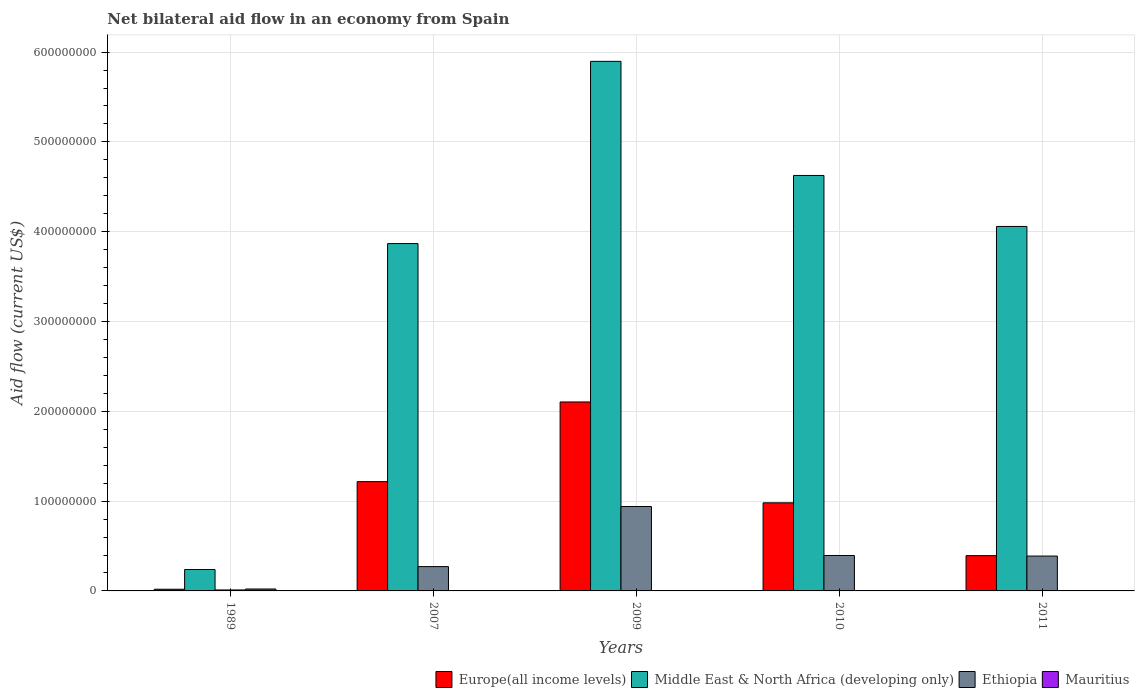How many different coloured bars are there?
Offer a very short reply. 4. Are the number of bars per tick equal to the number of legend labels?
Offer a terse response. Yes. How many bars are there on the 3rd tick from the left?
Give a very brief answer. 4. What is the label of the 1st group of bars from the left?
Your answer should be compact. 1989. What is the net bilateral aid flow in Europe(all income levels) in 1989?
Make the answer very short. 1.87e+06. Across all years, what is the maximum net bilateral aid flow in Ethiopia?
Make the answer very short. 9.40e+07. Across all years, what is the minimum net bilateral aid flow in Europe(all income levels)?
Make the answer very short. 1.87e+06. In which year was the net bilateral aid flow in Europe(all income levels) maximum?
Provide a short and direct response. 2009. In which year was the net bilateral aid flow in Europe(all income levels) minimum?
Offer a terse response. 1989. What is the total net bilateral aid flow in Middle East & North Africa (developing only) in the graph?
Your answer should be very brief. 1.87e+09. What is the difference between the net bilateral aid flow in Ethiopia in 1989 and that in 2010?
Your answer should be compact. -3.84e+07. What is the difference between the net bilateral aid flow in Europe(all income levels) in 2007 and the net bilateral aid flow in Mauritius in 2011?
Keep it short and to the point. 1.22e+08. What is the average net bilateral aid flow in Ethiopia per year?
Ensure brevity in your answer.  4.01e+07. In the year 2010, what is the difference between the net bilateral aid flow in Middle East & North Africa (developing only) and net bilateral aid flow in Mauritius?
Your answer should be very brief. 4.63e+08. What is the ratio of the net bilateral aid flow in Ethiopia in 1989 to that in 2011?
Provide a short and direct response. 0.03. Is the difference between the net bilateral aid flow in Middle East & North Africa (developing only) in 1989 and 2007 greater than the difference between the net bilateral aid flow in Mauritius in 1989 and 2007?
Your response must be concise. No. What is the difference between the highest and the second highest net bilateral aid flow in Ethiopia?
Ensure brevity in your answer.  5.45e+07. What is the difference between the highest and the lowest net bilateral aid flow in Ethiopia?
Provide a succinct answer. 9.29e+07. In how many years, is the net bilateral aid flow in Middle East & North Africa (developing only) greater than the average net bilateral aid flow in Middle East & North Africa (developing only) taken over all years?
Your response must be concise. 4. What does the 2nd bar from the left in 2010 represents?
Keep it short and to the point. Middle East & North Africa (developing only). What does the 3rd bar from the right in 2011 represents?
Your answer should be very brief. Middle East & North Africa (developing only). How many bars are there?
Ensure brevity in your answer.  20. What is the difference between two consecutive major ticks on the Y-axis?
Keep it short and to the point. 1.00e+08. Does the graph contain any zero values?
Make the answer very short. No. Does the graph contain grids?
Keep it short and to the point. Yes. How many legend labels are there?
Keep it short and to the point. 4. How are the legend labels stacked?
Offer a terse response. Horizontal. What is the title of the graph?
Provide a short and direct response. Net bilateral aid flow in an economy from Spain. What is the label or title of the Y-axis?
Give a very brief answer. Aid flow (current US$). What is the Aid flow (current US$) of Europe(all income levels) in 1989?
Offer a very short reply. 1.87e+06. What is the Aid flow (current US$) in Middle East & North Africa (developing only) in 1989?
Give a very brief answer. 2.38e+07. What is the Aid flow (current US$) in Ethiopia in 1989?
Your response must be concise. 1.09e+06. What is the Aid flow (current US$) in Mauritius in 1989?
Your answer should be very brief. 2.14e+06. What is the Aid flow (current US$) in Europe(all income levels) in 2007?
Offer a terse response. 1.22e+08. What is the Aid flow (current US$) of Middle East & North Africa (developing only) in 2007?
Ensure brevity in your answer.  3.87e+08. What is the Aid flow (current US$) in Ethiopia in 2007?
Ensure brevity in your answer.  2.71e+07. What is the Aid flow (current US$) of Mauritius in 2007?
Your response must be concise. 10000. What is the Aid flow (current US$) in Europe(all income levels) in 2009?
Your answer should be very brief. 2.10e+08. What is the Aid flow (current US$) in Middle East & North Africa (developing only) in 2009?
Provide a succinct answer. 5.90e+08. What is the Aid flow (current US$) of Ethiopia in 2009?
Offer a terse response. 9.40e+07. What is the Aid flow (current US$) in Mauritius in 2009?
Give a very brief answer. 2.00e+04. What is the Aid flow (current US$) of Europe(all income levels) in 2010?
Offer a terse response. 9.81e+07. What is the Aid flow (current US$) in Middle East & North Africa (developing only) in 2010?
Offer a very short reply. 4.63e+08. What is the Aid flow (current US$) of Ethiopia in 2010?
Give a very brief answer. 3.95e+07. What is the Aid flow (current US$) in Europe(all income levels) in 2011?
Keep it short and to the point. 3.93e+07. What is the Aid flow (current US$) in Middle East & North Africa (developing only) in 2011?
Make the answer very short. 4.06e+08. What is the Aid flow (current US$) of Ethiopia in 2011?
Keep it short and to the point. 3.88e+07. What is the Aid flow (current US$) of Mauritius in 2011?
Keep it short and to the point. 3.00e+04. Across all years, what is the maximum Aid flow (current US$) in Europe(all income levels)?
Your answer should be very brief. 2.10e+08. Across all years, what is the maximum Aid flow (current US$) of Middle East & North Africa (developing only)?
Provide a succinct answer. 5.90e+08. Across all years, what is the maximum Aid flow (current US$) in Ethiopia?
Give a very brief answer. 9.40e+07. Across all years, what is the maximum Aid flow (current US$) in Mauritius?
Provide a short and direct response. 2.14e+06. Across all years, what is the minimum Aid flow (current US$) of Europe(all income levels)?
Make the answer very short. 1.87e+06. Across all years, what is the minimum Aid flow (current US$) in Middle East & North Africa (developing only)?
Keep it short and to the point. 2.38e+07. Across all years, what is the minimum Aid flow (current US$) of Ethiopia?
Your answer should be compact. 1.09e+06. Across all years, what is the minimum Aid flow (current US$) in Mauritius?
Your answer should be very brief. 10000. What is the total Aid flow (current US$) of Europe(all income levels) in the graph?
Ensure brevity in your answer.  4.71e+08. What is the total Aid flow (current US$) in Middle East & North Africa (developing only) in the graph?
Provide a succinct answer. 1.87e+09. What is the total Aid flow (current US$) of Ethiopia in the graph?
Your response must be concise. 2.00e+08. What is the total Aid flow (current US$) of Mauritius in the graph?
Offer a terse response. 2.23e+06. What is the difference between the Aid flow (current US$) of Europe(all income levels) in 1989 and that in 2007?
Make the answer very short. -1.20e+08. What is the difference between the Aid flow (current US$) of Middle East & North Africa (developing only) in 1989 and that in 2007?
Make the answer very short. -3.63e+08. What is the difference between the Aid flow (current US$) in Ethiopia in 1989 and that in 2007?
Provide a succinct answer. -2.60e+07. What is the difference between the Aid flow (current US$) of Mauritius in 1989 and that in 2007?
Make the answer very short. 2.13e+06. What is the difference between the Aid flow (current US$) in Europe(all income levels) in 1989 and that in 2009?
Keep it short and to the point. -2.09e+08. What is the difference between the Aid flow (current US$) in Middle East & North Africa (developing only) in 1989 and that in 2009?
Your answer should be very brief. -5.66e+08. What is the difference between the Aid flow (current US$) in Ethiopia in 1989 and that in 2009?
Your answer should be compact. -9.29e+07. What is the difference between the Aid flow (current US$) in Mauritius in 1989 and that in 2009?
Provide a short and direct response. 2.12e+06. What is the difference between the Aid flow (current US$) of Europe(all income levels) in 1989 and that in 2010?
Offer a terse response. -9.62e+07. What is the difference between the Aid flow (current US$) in Middle East & North Africa (developing only) in 1989 and that in 2010?
Ensure brevity in your answer.  -4.39e+08. What is the difference between the Aid flow (current US$) of Ethiopia in 1989 and that in 2010?
Make the answer very short. -3.84e+07. What is the difference between the Aid flow (current US$) of Mauritius in 1989 and that in 2010?
Give a very brief answer. 2.11e+06. What is the difference between the Aid flow (current US$) in Europe(all income levels) in 1989 and that in 2011?
Your answer should be very brief. -3.74e+07. What is the difference between the Aid flow (current US$) in Middle East & North Africa (developing only) in 1989 and that in 2011?
Provide a succinct answer. -3.82e+08. What is the difference between the Aid flow (current US$) of Ethiopia in 1989 and that in 2011?
Your answer should be compact. -3.77e+07. What is the difference between the Aid flow (current US$) of Mauritius in 1989 and that in 2011?
Offer a terse response. 2.11e+06. What is the difference between the Aid flow (current US$) of Europe(all income levels) in 2007 and that in 2009?
Make the answer very short. -8.87e+07. What is the difference between the Aid flow (current US$) of Middle East & North Africa (developing only) in 2007 and that in 2009?
Provide a short and direct response. -2.03e+08. What is the difference between the Aid flow (current US$) in Ethiopia in 2007 and that in 2009?
Make the answer very short. -6.69e+07. What is the difference between the Aid flow (current US$) in Mauritius in 2007 and that in 2009?
Ensure brevity in your answer.  -10000. What is the difference between the Aid flow (current US$) in Europe(all income levels) in 2007 and that in 2010?
Provide a succinct answer. 2.36e+07. What is the difference between the Aid flow (current US$) in Middle East & North Africa (developing only) in 2007 and that in 2010?
Keep it short and to the point. -7.59e+07. What is the difference between the Aid flow (current US$) in Ethiopia in 2007 and that in 2010?
Provide a succinct answer. -1.24e+07. What is the difference between the Aid flow (current US$) in Europe(all income levels) in 2007 and that in 2011?
Make the answer very short. 8.24e+07. What is the difference between the Aid flow (current US$) in Middle East & North Africa (developing only) in 2007 and that in 2011?
Give a very brief answer. -1.91e+07. What is the difference between the Aid flow (current US$) in Ethiopia in 2007 and that in 2011?
Your answer should be compact. -1.17e+07. What is the difference between the Aid flow (current US$) of Europe(all income levels) in 2009 and that in 2010?
Make the answer very short. 1.12e+08. What is the difference between the Aid flow (current US$) of Middle East & North Africa (developing only) in 2009 and that in 2010?
Offer a terse response. 1.27e+08. What is the difference between the Aid flow (current US$) in Ethiopia in 2009 and that in 2010?
Your answer should be compact. 5.45e+07. What is the difference between the Aid flow (current US$) of Mauritius in 2009 and that in 2010?
Your answer should be compact. -10000. What is the difference between the Aid flow (current US$) in Europe(all income levels) in 2009 and that in 2011?
Make the answer very short. 1.71e+08. What is the difference between the Aid flow (current US$) of Middle East & North Africa (developing only) in 2009 and that in 2011?
Offer a very short reply. 1.84e+08. What is the difference between the Aid flow (current US$) in Ethiopia in 2009 and that in 2011?
Offer a terse response. 5.52e+07. What is the difference between the Aid flow (current US$) in Europe(all income levels) in 2010 and that in 2011?
Your answer should be very brief. 5.88e+07. What is the difference between the Aid flow (current US$) of Middle East & North Africa (developing only) in 2010 and that in 2011?
Your answer should be very brief. 5.68e+07. What is the difference between the Aid flow (current US$) of Ethiopia in 2010 and that in 2011?
Your answer should be compact. 6.40e+05. What is the difference between the Aid flow (current US$) of Europe(all income levels) in 1989 and the Aid flow (current US$) of Middle East & North Africa (developing only) in 2007?
Offer a terse response. -3.85e+08. What is the difference between the Aid flow (current US$) of Europe(all income levels) in 1989 and the Aid flow (current US$) of Ethiopia in 2007?
Give a very brief answer. -2.52e+07. What is the difference between the Aid flow (current US$) of Europe(all income levels) in 1989 and the Aid flow (current US$) of Mauritius in 2007?
Offer a very short reply. 1.86e+06. What is the difference between the Aid flow (current US$) of Middle East & North Africa (developing only) in 1989 and the Aid flow (current US$) of Ethiopia in 2007?
Give a very brief answer. -3.23e+06. What is the difference between the Aid flow (current US$) of Middle East & North Africa (developing only) in 1989 and the Aid flow (current US$) of Mauritius in 2007?
Give a very brief answer. 2.38e+07. What is the difference between the Aid flow (current US$) of Ethiopia in 1989 and the Aid flow (current US$) of Mauritius in 2007?
Offer a very short reply. 1.08e+06. What is the difference between the Aid flow (current US$) of Europe(all income levels) in 1989 and the Aid flow (current US$) of Middle East & North Africa (developing only) in 2009?
Offer a very short reply. -5.88e+08. What is the difference between the Aid flow (current US$) of Europe(all income levels) in 1989 and the Aid flow (current US$) of Ethiopia in 2009?
Your answer should be very brief. -9.21e+07. What is the difference between the Aid flow (current US$) of Europe(all income levels) in 1989 and the Aid flow (current US$) of Mauritius in 2009?
Provide a succinct answer. 1.85e+06. What is the difference between the Aid flow (current US$) of Middle East & North Africa (developing only) in 1989 and the Aid flow (current US$) of Ethiopia in 2009?
Your answer should be compact. -7.02e+07. What is the difference between the Aid flow (current US$) of Middle East & North Africa (developing only) in 1989 and the Aid flow (current US$) of Mauritius in 2009?
Offer a terse response. 2.38e+07. What is the difference between the Aid flow (current US$) of Ethiopia in 1989 and the Aid flow (current US$) of Mauritius in 2009?
Ensure brevity in your answer.  1.07e+06. What is the difference between the Aid flow (current US$) of Europe(all income levels) in 1989 and the Aid flow (current US$) of Middle East & North Africa (developing only) in 2010?
Make the answer very short. -4.61e+08. What is the difference between the Aid flow (current US$) of Europe(all income levels) in 1989 and the Aid flow (current US$) of Ethiopia in 2010?
Ensure brevity in your answer.  -3.76e+07. What is the difference between the Aid flow (current US$) in Europe(all income levels) in 1989 and the Aid flow (current US$) in Mauritius in 2010?
Make the answer very short. 1.84e+06. What is the difference between the Aid flow (current US$) of Middle East & North Africa (developing only) in 1989 and the Aid flow (current US$) of Ethiopia in 2010?
Your answer should be compact. -1.56e+07. What is the difference between the Aid flow (current US$) in Middle East & North Africa (developing only) in 1989 and the Aid flow (current US$) in Mauritius in 2010?
Ensure brevity in your answer.  2.38e+07. What is the difference between the Aid flow (current US$) of Ethiopia in 1989 and the Aid flow (current US$) of Mauritius in 2010?
Offer a terse response. 1.06e+06. What is the difference between the Aid flow (current US$) in Europe(all income levels) in 1989 and the Aid flow (current US$) in Middle East & North Africa (developing only) in 2011?
Ensure brevity in your answer.  -4.04e+08. What is the difference between the Aid flow (current US$) of Europe(all income levels) in 1989 and the Aid flow (current US$) of Ethiopia in 2011?
Ensure brevity in your answer.  -3.70e+07. What is the difference between the Aid flow (current US$) in Europe(all income levels) in 1989 and the Aid flow (current US$) in Mauritius in 2011?
Provide a short and direct response. 1.84e+06. What is the difference between the Aid flow (current US$) of Middle East & North Africa (developing only) in 1989 and the Aid flow (current US$) of Ethiopia in 2011?
Provide a succinct answer. -1.50e+07. What is the difference between the Aid flow (current US$) of Middle East & North Africa (developing only) in 1989 and the Aid flow (current US$) of Mauritius in 2011?
Keep it short and to the point. 2.38e+07. What is the difference between the Aid flow (current US$) in Ethiopia in 1989 and the Aid flow (current US$) in Mauritius in 2011?
Your answer should be very brief. 1.06e+06. What is the difference between the Aid flow (current US$) in Europe(all income levels) in 2007 and the Aid flow (current US$) in Middle East & North Africa (developing only) in 2009?
Ensure brevity in your answer.  -4.68e+08. What is the difference between the Aid flow (current US$) in Europe(all income levels) in 2007 and the Aid flow (current US$) in Ethiopia in 2009?
Ensure brevity in your answer.  2.77e+07. What is the difference between the Aid flow (current US$) of Europe(all income levels) in 2007 and the Aid flow (current US$) of Mauritius in 2009?
Keep it short and to the point. 1.22e+08. What is the difference between the Aid flow (current US$) of Middle East & North Africa (developing only) in 2007 and the Aid flow (current US$) of Ethiopia in 2009?
Offer a very short reply. 2.93e+08. What is the difference between the Aid flow (current US$) in Middle East & North Africa (developing only) in 2007 and the Aid flow (current US$) in Mauritius in 2009?
Make the answer very short. 3.87e+08. What is the difference between the Aid flow (current US$) in Ethiopia in 2007 and the Aid flow (current US$) in Mauritius in 2009?
Your answer should be compact. 2.71e+07. What is the difference between the Aid flow (current US$) of Europe(all income levels) in 2007 and the Aid flow (current US$) of Middle East & North Africa (developing only) in 2010?
Provide a succinct answer. -3.41e+08. What is the difference between the Aid flow (current US$) of Europe(all income levels) in 2007 and the Aid flow (current US$) of Ethiopia in 2010?
Provide a short and direct response. 8.22e+07. What is the difference between the Aid flow (current US$) in Europe(all income levels) in 2007 and the Aid flow (current US$) in Mauritius in 2010?
Ensure brevity in your answer.  1.22e+08. What is the difference between the Aid flow (current US$) of Middle East & North Africa (developing only) in 2007 and the Aid flow (current US$) of Ethiopia in 2010?
Ensure brevity in your answer.  3.47e+08. What is the difference between the Aid flow (current US$) of Middle East & North Africa (developing only) in 2007 and the Aid flow (current US$) of Mauritius in 2010?
Your answer should be compact. 3.87e+08. What is the difference between the Aid flow (current US$) of Ethiopia in 2007 and the Aid flow (current US$) of Mauritius in 2010?
Your response must be concise. 2.70e+07. What is the difference between the Aid flow (current US$) of Europe(all income levels) in 2007 and the Aid flow (current US$) of Middle East & North Africa (developing only) in 2011?
Offer a terse response. -2.84e+08. What is the difference between the Aid flow (current US$) in Europe(all income levels) in 2007 and the Aid flow (current US$) in Ethiopia in 2011?
Ensure brevity in your answer.  8.29e+07. What is the difference between the Aid flow (current US$) of Europe(all income levels) in 2007 and the Aid flow (current US$) of Mauritius in 2011?
Your answer should be very brief. 1.22e+08. What is the difference between the Aid flow (current US$) in Middle East & North Africa (developing only) in 2007 and the Aid flow (current US$) in Ethiopia in 2011?
Your response must be concise. 3.48e+08. What is the difference between the Aid flow (current US$) of Middle East & North Africa (developing only) in 2007 and the Aid flow (current US$) of Mauritius in 2011?
Your answer should be compact. 3.87e+08. What is the difference between the Aid flow (current US$) in Ethiopia in 2007 and the Aid flow (current US$) in Mauritius in 2011?
Provide a succinct answer. 2.70e+07. What is the difference between the Aid flow (current US$) in Europe(all income levels) in 2009 and the Aid flow (current US$) in Middle East & North Africa (developing only) in 2010?
Make the answer very short. -2.52e+08. What is the difference between the Aid flow (current US$) in Europe(all income levels) in 2009 and the Aid flow (current US$) in Ethiopia in 2010?
Provide a short and direct response. 1.71e+08. What is the difference between the Aid flow (current US$) of Europe(all income levels) in 2009 and the Aid flow (current US$) of Mauritius in 2010?
Ensure brevity in your answer.  2.10e+08. What is the difference between the Aid flow (current US$) in Middle East & North Africa (developing only) in 2009 and the Aid flow (current US$) in Ethiopia in 2010?
Provide a succinct answer. 5.50e+08. What is the difference between the Aid flow (current US$) of Middle East & North Africa (developing only) in 2009 and the Aid flow (current US$) of Mauritius in 2010?
Provide a succinct answer. 5.90e+08. What is the difference between the Aid flow (current US$) in Ethiopia in 2009 and the Aid flow (current US$) in Mauritius in 2010?
Offer a very short reply. 9.40e+07. What is the difference between the Aid flow (current US$) of Europe(all income levels) in 2009 and the Aid flow (current US$) of Middle East & North Africa (developing only) in 2011?
Give a very brief answer. -1.95e+08. What is the difference between the Aid flow (current US$) in Europe(all income levels) in 2009 and the Aid flow (current US$) in Ethiopia in 2011?
Your response must be concise. 1.72e+08. What is the difference between the Aid flow (current US$) of Europe(all income levels) in 2009 and the Aid flow (current US$) of Mauritius in 2011?
Offer a very short reply. 2.10e+08. What is the difference between the Aid flow (current US$) in Middle East & North Africa (developing only) in 2009 and the Aid flow (current US$) in Ethiopia in 2011?
Provide a succinct answer. 5.51e+08. What is the difference between the Aid flow (current US$) in Middle East & North Africa (developing only) in 2009 and the Aid flow (current US$) in Mauritius in 2011?
Offer a terse response. 5.90e+08. What is the difference between the Aid flow (current US$) of Ethiopia in 2009 and the Aid flow (current US$) of Mauritius in 2011?
Give a very brief answer. 9.40e+07. What is the difference between the Aid flow (current US$) in Europe(all income levels) in 2010 and the Aid flow (current US$) in Middle East & North Africa (developing only) in 2011?
Your answer should be compact. -3.08e+08. What is the difference between the Aid flow (current US$) of Europe(all income levels) in 2010 and the Aid flow (current US$) of Ethiopia in 2011?
Provide a short and direct response. 5.93e+07. What is the difference between the Aid flow (current US$) in Europe(all income levels) in 2010 and the Aid flow (current US$) in Mauritius in 2011?
Provide a succinct answer. 9.81e+07. What is the difference between the Aid flow (current US$) in Middle East & North Africa (developing only) in 2010 and the Aid flow (current US$) in Ethiopia in 2011?
Offer a very short reply. 4.24e+08. What is the difference between the Aid flow (current US$) of Middle East & North Africa (developing only) in 2010 and the Aid flow (current US$) of Mauritius in 2011?
Your answer should be very brief. 4.63e+08. What is the difference between the Aid flow (current US$) in Ethiopia in 2010 and the Aid flow (current US$) in Mauritius in 2011?
Give a very brief answer. 3.94e+07. What is the average Aid flow (current US$) in Europe(all income levels) per year?
Provide a short and direct response. 9.43e+07. What is the average Aid flow (current US$) of Middle East & North Africa (developing only) per year?
Your response must be concise. 3.74e+08. What is the average Aid flow (current US$) in Ethiopia per year?
Give a very brief answer. 4.01e+07. What is the average Aid flow (current US$) of Mauritius per year?
Make the answer very short. 4.46e+05. In the year 1989, what is the difference between the Aid flow (current US$) of Europe(all income levels) and Aid flow (current US$) of Middle East & North Africa (developing only)?
Give a very brief answer. -2.20e+07. In the year 1989, what is the difference between the Aid flow (current US$) in Europe(all income levels) and Aid flow (current US$) in Ethiopia?
Give a very brief answer. 7.80e+05. In the year 1989, what is the difference between the Aid flow (current US$) in Europe(all income levels) and Aid flow (current US$) in Mauritius?
Keep it short and to the point. -2.70e+05. In the year 1989, what is the difference between the Aid flow (current US$) of Middle East & North Africa (developing only) and Aid flow (current US$) of Ethiopia?
Offer a terse response. 2.28e+07. In the year 1989, what is the difference between the Aid flow (current US$) of Middle East & North Africa (developing only) and Aid flow (current US$) of Mauritius?
Provide a succinct answer. 2.17e+07. In the year 1989, what is the difference between the Aid flow (current US$) in Ethiopia and Aid flow (current US$) in Mauritius?
Offer a very short reply. -1.05e+06. In the year 2007, what is the difference between the Aid flow (current US$) of Europe(all income levels) and Aid flow (current US$) of Middle East & North Africa (developing only)?
Provide a succinct answer. -2.65e+08. In the year 2007, what is the difference between the Aid flow (current US$) in Europe(all income levels) and Aid flow (current US$) in Ethiopia?
Make the answer very short. 9.46e+07. In the year 2007, what is the difference between the Aid flow (current US$) of Europe(all income levels) and Aid flow (current US$) of Mauritius?
Offer a very short reply. 1.22e+08. In the year 2007, what is the difference between the Aid flow (current US$) of Middle East & North Africa (developing only) and Aid flow (current US$) of Ethiopia?
Your response must be concise. 3.60e+08. In the year 2007, what is the difference between the Aid flow (current US$) in Middle East & North Africa (developing only) and Aid flow (current US$) in Mauritius?
Provide a succinct answer. 3.87e+08. In the year 2007, what is the difference between the Aid flow (current US$) in Ethiopia and Aid flow (current US$) in Mauritius?
Your answer should be very brief. 2.71e+07. In the year 2009, what is the difference between the Aid flow (current US$) of Europe(all income levels) and Aid flow (current US$) of Middle East & North Africa (developing only)?
Keep it short and to the point. -3.79e+08. In the year 2009, what is the difference between the Aid flow (current US$) of Europe(all income levels) and Aid flow (current US$) of Ethiopia?
Offer a very short reply. 1.16e+08. In the year 2009, what is the difference between the Aid flow (current US$) of Europe(all income levels) and Aid flow (current US$) of Mauritius?
Your answer should be compact. 2.10e+08. In the year 2009, what is the difference between the Aid flow (current US$) of Middle East & North Africa (developing only) and Aid flow (current US$) of Ethiopia?
Provide a short and direct response. 4.96e+08. In the year 2009, what is the difference between the Aid flow (current US$) of Middle East & North Africa (developing only) and Aid flow (current US$) of Mauritius?
Your answer should be very brief. 5.90e+08. In the year 2009, what is the difference between the Aid flow (current US$) of Ethiopia and Aid flow (current US$) of Mauritius?
Keep it short and to the point. 9.40e+07. In the year 2010, what is the difference between the Aid flow (current US$) in Europe(all income levels) and Aid flow (current US$) in Middle East & North Africa (developing only)?
Provide a short and direct response. -3.65e+08. In the year 2010, what is the difference between the Aid flow (current US$) in Europe(all income levels) and Aid flow (current US$) in Ethiopia?
Give a very brief answer. 5.86e+07. In the year 2010, what is the difference between the Aid flow (current US$) of Europe(all income levels) and Aid flow (current US$) of Mauritius?
Keep it short and to the point. 9.81e+07. In the year 2010, what is the difference between the Aid flow (current US$) in Middle East & North Africa (developing only) and Aid flow (current US$) in Ethiopia?
Provide a succinct answer. 4.23e+08. In the year 2010, what is the difference between the Aid flow (current US$) in Middle East & North Africa (developing only) and Aid flow (current US$) in Mauritius?
Your answer should be compact. 4.63e+08. In the year 2010, what is the difference between the Aid flow (current US$) of Ethiopia and Aid flow (current US$) of Mauritius?
Your answer should be very brief. 3.94e+07. In the year 2011, what is the difference between the Aid flow (current US$) in Europe(all income levels) and Aid flow (current US$) in Middle East & North Africa (developing only)?
Provide a short and direct response. -3.67e+08. In the year 2011, what is the difference between the Aid flow (current US$) in Europe(all income levels) and Aid flow (current US$) in Ethiopia?
Your answer should be very brief. 4.70e+05. In the year 2011, what is the difference between the Aid flow (current US$) in Europe(all income levels) and Aid flow (current US$) in Mauritius?
Keep it short and to the point. 3.93e+07. In the year 2011, what is the difference between the Aid flow (current US$) of Middle East & North Africa (developing only) and Aid flow (current US$) of Ethiopia?
Offer a terse response. 3.67e+08. In the year 2011, what is the difference between the Aid flow (current US$) of Middle East & North Africa (developing only) and Aid flow (current US$) of Mauritius?
Make the answer very short. 4.06e+08. In the year 2011, what is the difference between the Aid flow (current US$) in Ethiopia and Aid flow (current US$) in Mauritius?
Give a very brief answer. 3.88e+07. What is the ratio of the Aid flow (current US$) in Europe(all income levels) in 1989 to that in 2007?
Provide a short and direct response. 0.02. What is the ratio of the Aid flow (current US$) in Middle East & North Africa (developing only) in 1989 to that in 2007?
Your response must be concise. 0.06. What is the ratio of the Aid flow (current US$) in Ethiopia in 1989 to that in 2007?
Your response must be concise. 0.04. What is the ratio of the Aid flow (current US$) in Mauritius in 1989 to that in 2007?
Make the answer very short. 214. What is the ratio of the Aid flow (current US$) of Europe(all income levels) in 1989 to that in 2009?
Make the answer very short. 0.01. What is the ratio of the Aid flow (current US$) in Middle East & North Africa (developing only) in 1989 to that in 2009?
Your answer should be compact. 0.04. What is the ratio of the Aid flow (current US$) of Ethiopia in 1989 to that in 2009?
Provide a short and direct response. 0.01. What is the ratio of the Aid flow (current US$) of Mauritius in 1989 to that in 2009?
Your response must be concise. 107. What is the ratio of the Aid flow (current US$) of Europe(all income levels) in 1989 to that in 2010?
Keep it short and to the point. 0.02. What is the ratio of the Aid flow (current US$) of Middle East & North Africa (developing only) in 1989 to that in 2010?
Provide a succinct answer. 0.05. What is the ratio of the Aid flow (current US$) in Ethiopia in 1989 to that in 2010?
Your answer should be very brief. 0.03. What is the ratio of the Aid flow (current US$) in Mauritius in 1989 to that in 2010?
Your response must be concise. 71.33. What is the ratio of the Aid flow (current US$) of Europe(all income levels) in 1989 to that in 2011?
Offer a terse response. 0.05. What is the ratio of the Aid flow (current US$) in Middle East & North Africa (developing only) in 1989 to that in 2011?
Your answer should be compact. 0.06. What is the ratio of the Aid flow (current US$) of Ethiopia in 1989 to that in 2011?
Keep it short and to the point. 0.03. What is the ratio of the Aid flow (current US$) of Mauritius in 1989 to that in 2011?
Give a very brief answer. 71.33. What is the ratio of the Aid flow (current US$) in Europe(all income levels) in 2007 to that in 2009?
Your response must be concise. 0.58. What is the ratio of the Aid flow (current US$) in Middle East & North Africa (developing only) in 2007 to that in 2009?
Ensure brevity in your answer.  0.66. What is the ratio of the Aid flow (current US$) in Ethiopia in 2007 to that in 2009?
Ensure brevity in your answer.  0.29. What is the ratio of the Aid flow (current US$) in Europe(all income levels) in 2007 to that in 2010?
Give a very brief answer. 1.24. What is the ratio of the Aid flow (current US$) of Middle East & North Africa (developing only) in 2007 to that in 2010?
Provide a succinct answer. 0.84. What is the ratio of the Aid flow (current US$) of Ethiopia in 2007 to that in 2010?
Offer a terse response. 0.69. What is the ratio of the Aid flow (current US$) in Mauritius in 2007 to that in 2010?
Provide a succinct answer. 0.33. What is the ratio of the Aid flow (current US$) in Europe(all income levels) in 2007 to that in 2011?
Give a very brief answer. 3.1. What is the ratio of the Aid flow (current US$) of Middle East & North Africa (developing only) in 2007 to that in 2011?
Provide a succinct answer. 0.95. What is the ratio of the Aid flow (current US$) of Ethiopia in 2007 to that in 2011?
Your response must be concise. 0.7. What is the ratio of the Aid flow (current US$) of Europe(all income levels) in 2009 to that in 2010?
Your response must be concise. 2.14. What is the ratio of the Aid flow (current US$) in Middle East & North Africa (developing only) in 2009 to that in 2010?
Your answer should be very brief. 1.27. What is the ratio of the Aid flow (current US$) of Ethiopia in 2009 to that in 2010?
Make the answer very short. 2.38. What is the ratio of the Aid flow (current US$) in Mauritius in 2009 to that in 2010?
Your answer should be very brief. 0.67. What is the ratio of the Aid flow (current US$) of Europe(all income levels) in 2009 to that in 2011?
Ensure brevity in your answer.  5.36. What is the ratio of the Aid flow (current US$) in Middle East & North Africa (developing only) in 2009 to that in 2011?
Your response must be concise. 1.45. What is the ratio of the Aid flow (current US$) in Ethiopia in 2009 to that in 2011?
Make the answer very short. 2.42. What is the ratio of the Aid flow (current US$) of Europe(all income levels) in 2010 to that in 2011?
Provide a short and direct response. 2.5. What is the ratio of the Aid flow (current US$) of Middle East & North Africa (developing only) in 2010 to that in 2011?
Keep it short and to the point. 1.14. What is the ratio of the Aid flow (current US$) in Ethiopia in 2010 to that in 2011?
Your answer should be compact. 1.02. What is the difference between the highest and the second highest Aid flow (current US$) of Europe(all income levels)?
Your answer should be compact. 8.87e+07. What is the difference between the highest and the second highest Aid flow (current US$) of Middle East & North Africa (developing only)?
Provide a short and direct response. 1.27e+08. What is the difference between the highest and the second highest Aid flow (current US$) of Ethiopia?
Ensure brevity in your answer.  5.45e+07. What is the difference between the highest and the second highest Aid flow (current US$) of Mauritius?
Offer a terse response. 2.11e+06. What is the difference between the highest and the lowest Aid flow (current US$) in Europe(all income levels)?
Your response must be concise. 2.09e+08. What is the difference between the highest and the lowest Aid flow (current US$) of Middle East & North Africa (developing only)?
Give a very brief answer. 5.66e+08. What is the difference between the highest and the lowest Aid flow (current US$) of Ethiopia?
Provide a short and direct response. 9.29e+07. What is the difference between the highest and the lowest Aid flow (current US$) of Mauritius?
Give a very brief answer. 2.13e+06. 